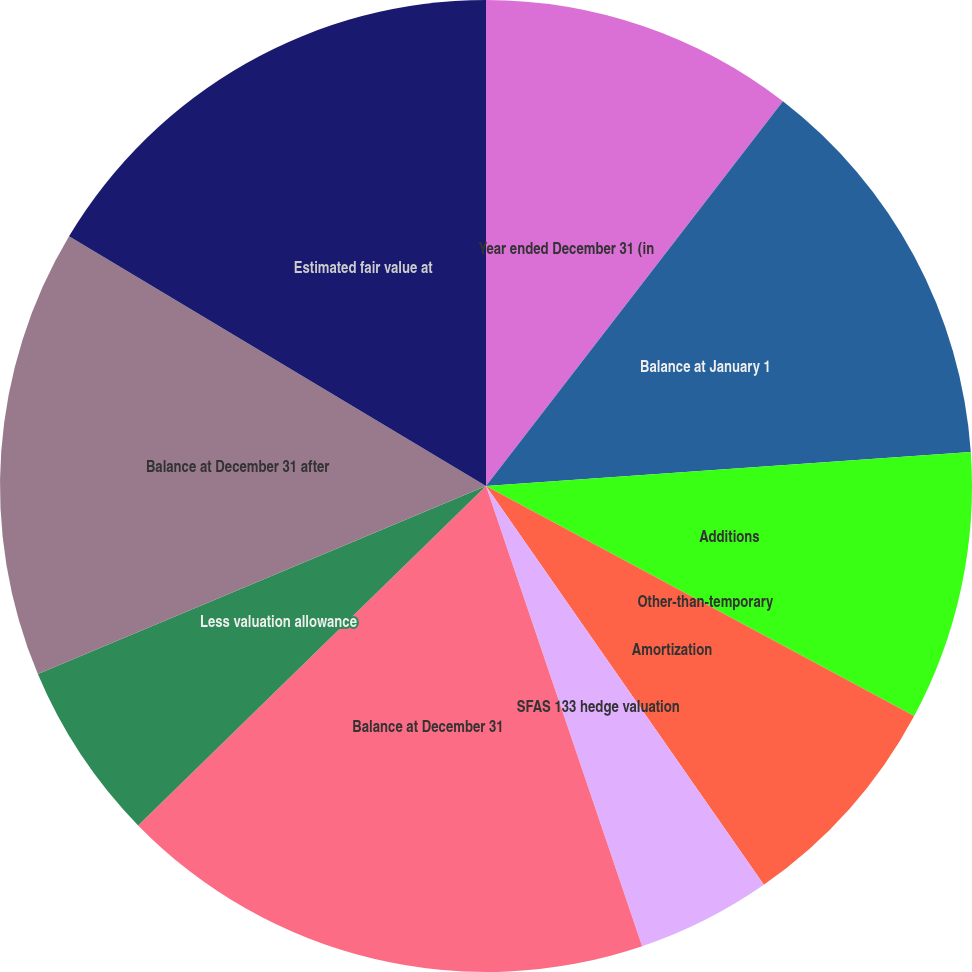Convert chart to OTSL. <chart><loc_0><loc_0><loc_500><loc_500><pie_chart><fcel>Year ended December 31 (in<fcel>Balance at January 1<fcel>Additions<fcel>Other-than-temporary<fcel>Amortization<fcel>SFAS 133 hedge valuation<fcel>Balance at December 31<fcel>Less valuation allowance<fcel>Balance at December 31 after<fcel>Estimated fair value at<nl><fcel>10.46%<fcel>13.42%<fcel>8.96%<fcel>0.0%<fcel>7.47%<fcel>4.48%<fcel>17.9%<fcel>5.98%<fcel>14.91%<fcel>16.41%<nl></chart> 